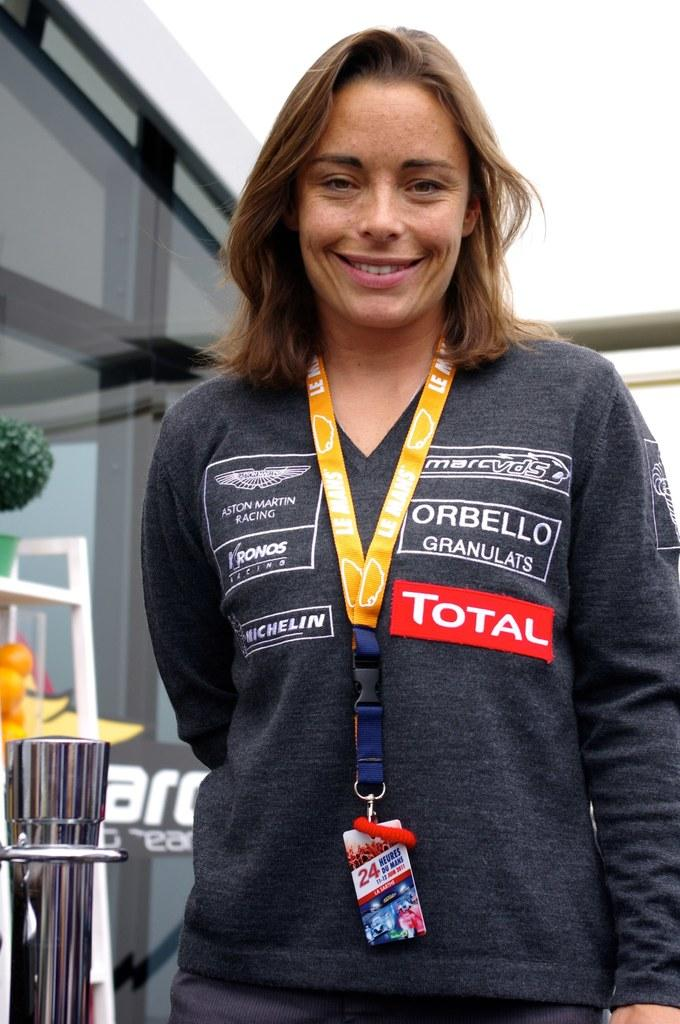<image>
Present a compact description of the photo's key features. A woman posing with Total written on her sweater 